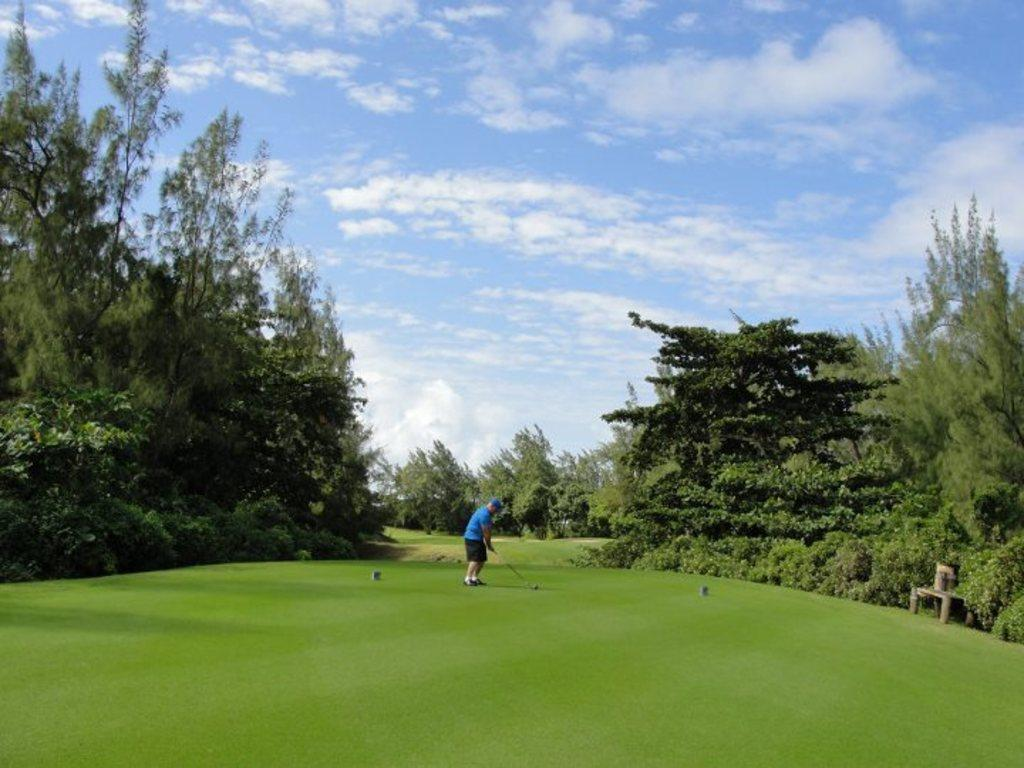What is the main subject of the image? The image shows a view of a golf club. Can you describe the person in the image? There is a man in the image, and he is wearing a blue t-shirt. What is the man holding in the image? The man is holding a golf stick. What can be seen in the sky in the image? The sky is visible in the image, and clouds are present. What type of science is being conducted at the golf club in the image? There is no indication of any scientific activity being conducted in the image; it simply shows a man at a golf club. What channel is the golf club located on in the image? The image is a photograph and not a television channel, so the concept of a channel does not apply. 